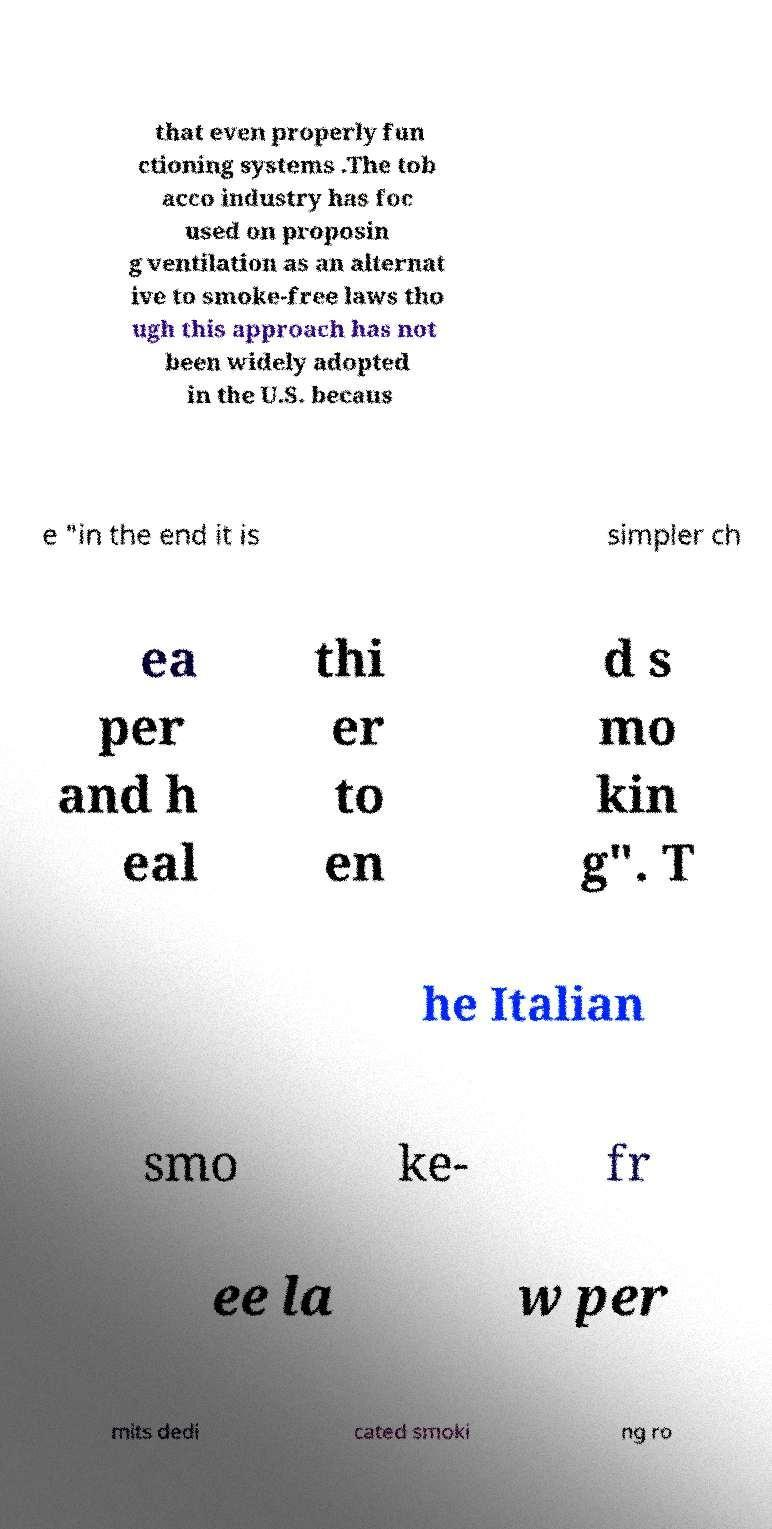For documentation purposes, I need the text within this image transcribed. Could you provide that? that even properly fun ctioning systems .The tob acco industry has foc used on proposin g ventilation as an alternat ive to smoke-free laws tho ugh this approach has not been widely adopted in the U.S. becaus e "in the end it is simpler ch ea per and h eal thi er to en d s mo kin g". T he Italian smo ke- fr ee la w per mits dedi cated smoki ng ro 